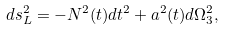Convert formula to latex. <formula><loc_0><loc_0><loc_500><loc_500>d s ^ { 2 } _ { L } = - N ^ { 2 } ( t ) d t ^ { 2 } + a ^ { 2 } ( t ) d \Omega _ { 3 } ^ { 2 } ,</formula> 